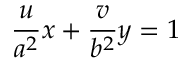<formula> <loc_0><loc_0><loc_500><loc_500>{ \frac { u } { a ^ { 2 } } } x + { \frac { v } { b ^ { 2 } } } y = 1</formula> 